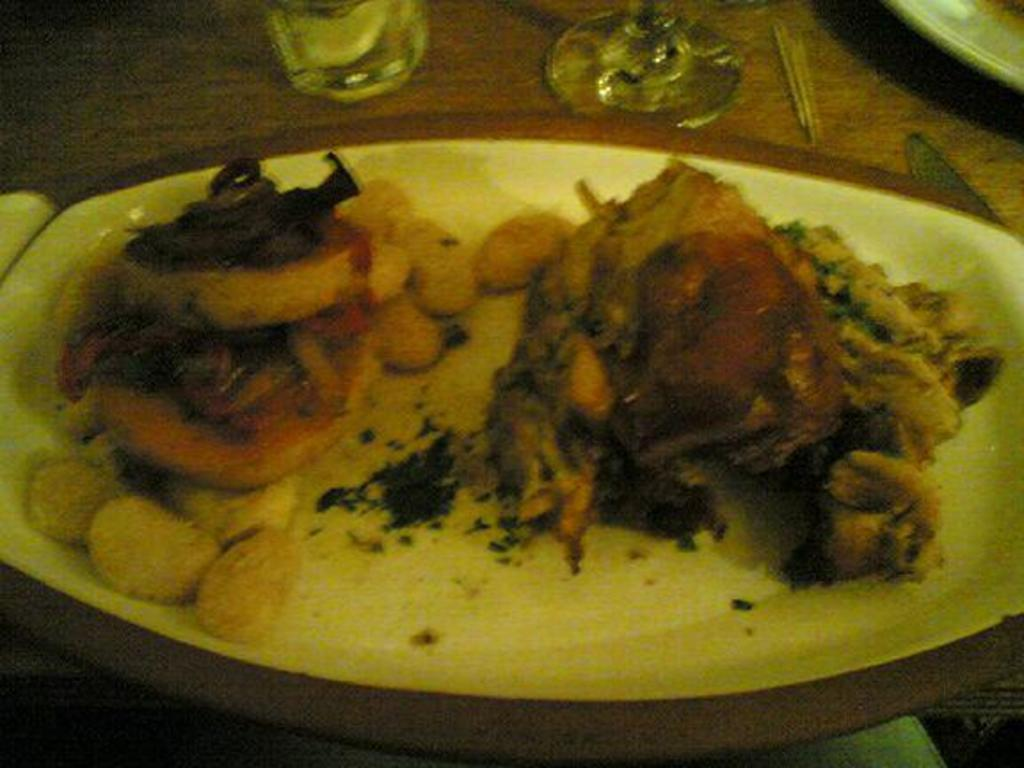What is on the plate that is visible in the image? There is a plate containing food in the image. What can be seen on the table besides the plate? There are glasses on the table. What utensil is visible in the image? A spoon is visible in the image. What other utensil is present in the image? A knife is present in the image. Where is the plate located on the table? There is a plate placed on the table in the right top of the image. Can you see the friend of the knife in the image? There is no friend of the knife present in the image; only the knife and other utensils and tableware are visible. 